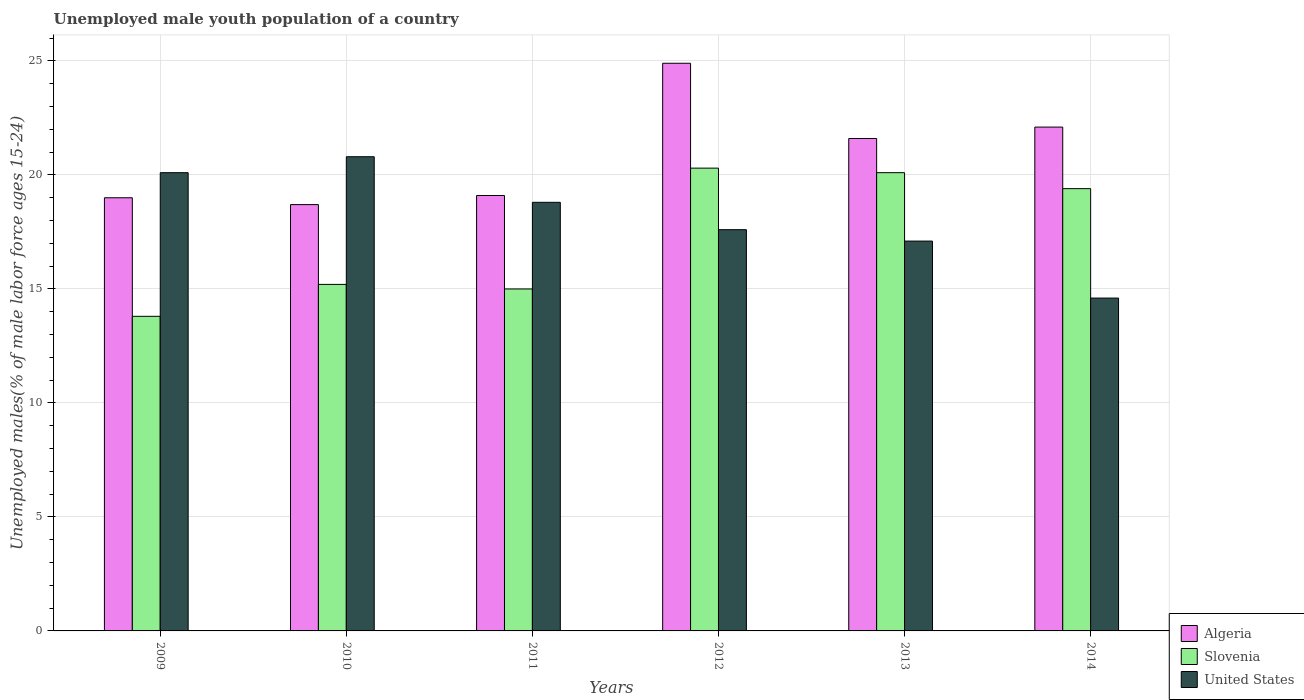How many groups of bars are there?
Your answer should be very brief. 6. Are the number of bars on each tick of the X-axis equal?
Give a very brief answer. Yes. How many bars are there on the 4th tick from the left?
Your answer should be very brief. 3. What is the percentage of unemployed male youth population in Slovenia in 2010?
Your answer should be very brief. 15.2. Across all years, what is the maximum percentage of unemployed male youth population in Slovenia?
Give a very brief answer. 20.3. Across all years, what is the minimum percentage of unemployed male youth population in Slovenia?
Offer a very short reply. 13.8. In which year was the percentage of unemployed male youth population in United States maximum?
Your answer should be very brief. 2010. In which year was the percentage of unemployed male youth population in Slovenia minimum?
Ensure brevity in your answer.  2009. What is the total percentage of unemployed male youth population in Algeria in the graph?
Make the answer very short. 125.4. What is the difference between the percentage of unemployed male youth population in Algeria in 2013 and that in 2014?
Offer a very short reply. -0.5. What is the difference between the percentage of unemployed male youth population in United States in 2014 and the percentage of unemployed male youth population in Slovenia in 2013?
Your answer should be very brief. -5.5. What is the average percentage of unemployed male youth population in United States per year?
Your response must be concise. 18.17. In the year 2014, what is the difference between the percentage of unemployed male youth population in Algeria and percentage of unemployed male youth population in Slovenia?
Your answer should be compact. 2.7. What is the ratio of the percentage of unemployed male youth population in Algeria in 2009 to that in 2011?
Your answer should be very brief. 0.99. Is the percentage of unemployed male youth population in Slovenia in 2010 less than that in 2012?
Your response must be concise. Yes. Is the difference between the percentage of unemployed male youth population in Algeria in 2010 and 2011 greater than the difference between the percentage of unemployed male youth population in Slovenia in 2010 and 2011?
Ensure brevity in your answer.  No. What is the difference between the highest and the second highest percentage of unemployed male youth population in United States?
Give a very brief answer. 0.7. What is the difference between the highest and the lowest percentage of unemployed male youth population in United States?
Offer a very short reply. 6.2. In how many years, is the percentage of unemployed male youth population in Algeria greater than the average percentage of unemployed male youth population in Algeria taken over all years?
Provide a succinct answer. 3. What does the 2nd bar from the left in 2014 represents?
Your answer should be compact. Slovenia. What does the 3rd bar from the right in 2014 represents?
Make the answer very short. Algeria. Is it the case that in every year, the sum of the percentage of unemployed male youth population in Algeria and percentage of unemployed male youth population in Slovenia is greater than the percentage of unemployed male youth population in United States?
Keep it short and to the point. Yes. How many bars are there?
Your answer should be compact. 18. Are all the bars in the graph horizontal?
Make the answer very short. No. How many years are there in the graph?
Provide a succinct answer. 6. Does the graph contain any zero values?
Keep it short and to the point. No. Where does the legend appear in the graph?
Offer a very short reply. Bottom right. What is the title of the graph?
Your answer should be very brief. Unemployed male youth population of a country. Does "Iraq" appear as one of the legend labels in the graph?
Offer a terse response. No. What is the label or title of the Y-axis?
Provide a short and direct response. Unemployed males(% of male labor force ages 15-24). What is the Unemployed males(% of male labor force ages 15-24) of Algeria in 2009?
Ensure brevity in your answer.  19. What is the Unemployed males(% of male labor force ages 15-24) in Slovenia in 2009?
Your response must be concise. 13.8. What is the Unemployed males(% of male labor force ages 15-24) of United States in 2009?
Provide a short and direct response. 20.1. What is the Unemployed males(% of male labor force ages 15-24) of Algeria in 2010?
Provide a short and direct response. 18.7. What is the Unemployed males(% of male labor force ages 15-24) in Slovenia in 2010?
Your response must be concise. 15.2. What is the Unemployed males(% of male labor force ages 15-24) of United States in 2010?
Offer a terse response. 20.8. What is the Unemployed males(% of male labor force ages 15-24) of Algeria in 2011?
Provide a succinct answer. 19.1. What is the Unemployed males(% of male labor force ages 15-24) of United States in 2011?
Your answer should be very brief. 18.8. What is the Unemployed males(% of male labor force ages 15-24) in Algeria in 2012?
Give a very brief answer. 24.9. What is the Unemployed males(% of male labor force ages 15-24) of Slovenia in 2012?
Provide a short and direct response. 20.3. What is the Unemployed males(% of male labor force ages 15-24) in United States in 2012?
Ensure brevity in your answer.  17.6. What is the Unemployed males(% of male labor force ages 15-24) of Algeria in 2013?
Offer a terse response. 21.6. What is the Unemployed males(% of male labor force ages 15-24) in Slovenia in 2013?
Provide a short and direct response. 20.1. What is the Unemployed males(% of male labor force ages 15-24) of United States in 2013?
Offer a very short reply. 17.1. What is the Unemployed males(% of male labor force ages 15-24) in Algeria in 2014?
Your response must be concise. 22.1. What is the Unemployed males(% of male labor force ages 15-24) in Slovenia in 2014?
Offer a very short reply. 19.4. What is the Unemployed males(% of male labor force ages 15-24) of United States in 2014?
Your answer should be compact. 14.6. Across all years, what is the maximum Unemployed males(% of male labor force ages 15-24) in Algeria?
Offer a terse response. 24.9. Across all years, what is the maximum Unemployed males(% of male labor force ages 15-24) of Slovenia?
Your answer should be very brief. 20.3. Across all years, what is the maximum Unemployed males(% of male labor force ages 15-24) in United States?
Ensure brevity in your answer.  20.8. Across all years, what is the minimum Unemployed males(% of male labor force ages 15-24) of Algeria?
Provide a short and direct response. 18.7. Across all years, what is the minimum Unemployed males(% of male labor force ages 15-24) in Slovenia?
Your answer should be very brief. 13.8. Across all years, what is the minimum Unemployed males(% of male labor force ages 15-24) in United States?
Keep it short and to the point. 14.6. What is the total Unemployed males(% of male labor force ages 15-24) of Algeria in the graph?
Make the answer very short. 125.4. What is the total Unemployed males(% of male labor force ages 15-24) of Slovenia in the graph?
Make the answer very short. 103.8. What is the total Unemployed males(% of male labor force ages 15-24) of United States in the graph?
Your response must be concise. 109. What is the difference between the Unemployed males(% of male labor force ages 15-24) of Slovenia in 2009 and that in 2010?
Provide a short and direct response. -1.4. What is the difference between the Unemployed males(% of male labor force ages 15-24) of United States in 2009 and that in 2010?
Offer a terse response. -0.7. What is the difference between the Unemployed males(% of male labor force ages 15-24) of Algeria in 2009 and that in 2011?
Provide a short and direct response. -0.1. What is the difference between the Unemployed males(% of male labor force ages 15-24) of United States in 2009 and that in 2011?
Offer a very short reply. 1.3. What is the difference between the Unemployed males(% of male labor force ages 15-24) of United States in 2009 and that in 2012?
Ensure brevity in your answer.  2.5. What is the difference between the Unemployed males(% of male labor force ages 15-24) of Algeria in 2009 and that in 2014?
Your answer should be very brief. -3.1. What is the difference between the Unemployed males(% of male labor force ages 15-24) in Slovenia in 2010 and that in 2011?
Keep it short and to the point. 0.2. What is the difference between the Unemployed males(% of male labor force ages 15-24) in Algeria in 2010 and that in 2012?
Your answer should be very brief. -6.2. What is the difference between the Unemployed males(% of male labor force ages 15-24) of United States in 2010 and that in 2012?
Ensure brevity in your answer.  3.2. What is the difference between the Unemployed males(% of male labor force ages 15-24) in Algeria in 2010 and that in 2013?
Offer a very short reply. -2.9. What is the difference between the Unemployed males(% of male labor force ages 15-24) of Slovenia in 2010 and that in 2013?
Offer a terse response. -4.9. What is the difference between the Unemployed males(% of male labor force ages 15-24) in Algeria in 2010 and that in 2014?
Keep it short and to the point. -3.4. What is the difference between the Unemployed males(% of male labor force ages 15-24) in Slovenia in 2010 and that in 2014?
Your answer should be very brief. -4.2. What is the difference between the Unemployed males(% of male labor force ages 15-24) of Slovenia in 2011 and that in 2012?
Your answer should be very brief. -5.3. What is the difference between the Unemployed males(% of male labor force ages 15-24) of United States in 2011 and that in 2012?
Your answer should be very brief. 1.2. What is the difference between the Unemployed males(% of male labor force ages 15-24) in Algeria in 2011 and that in 2013?
Your answer should be very brief. -2.5. What is the difference between the Unemployed males(% of male labor force ages 15-24) of Slovenia in 2011 and that in 2013?
Your answer should be very brief. -5.1. What is the difference between the Unemployed males(% of male labor force ages 15-24) in United States in 2011 and that in 2013?
Your answer should be very brief. 1.7. What is the difference between the Unemployed males(% of male labor force ages 15-24) of Algeria in 2011 and that in 2014?
Your answer should be compact. -3. What is the difference between the Unemployed males(% of male labor force ages 15-24) in Slovenia in 2011 and that in 2014?
Ensure brevity in your answer.  -4.4. What is the difference between the Unemployed males(% of male labor force ages 15-24) of Algeria in 2012 and that in 2013?
Your answer should be very brief. 3.3. What is the difference between the Unemployed males(% of male labor force ages 15-24) of Slovenia in 2012 and that in 2013?
Keep it short and to the point. 0.2. What is the difference between the Unemployed males(% of male labor force ages 15-24) of Algeria in 2012 and that in 2014?
Ensure brevity in your answer.  2.8. What is the difference between the Unemployed males(% of male labor force ages 15-24) of Algeria in 2013 and that in 2014?
Offer a terse response. -0.5. What is the difference between the Unemployed males(% of male labor force ages 15-24) in Slovenia in 2013 and that in 2014?
Make the answer very short. 0.7. What is the difference between the Unemployed males(% of male labor force ages 15-24) in Algeria in 2009 and the Unemployed males(% of male labor force ages 15-24) in Slovenia in 2010?
Your response must be concise. 3.8. What is the difference between the Unemployed males(% of male labor force ages 15-24) in Algeria in 2009 and the Unemployed males(% of male labor force ages 15-24) in United States in 2010?
Your answer should be very brief. -1.8. What is the difference between the Unemployed males(% of male labor force ages 15-24) in Algeria in 2009 and the Unemployed males(% of male labor force ages 15-24) in Slovenia in 2011?
Keep it short and to the point. 4. What is the difference between the Unemployed males(% of male labor force ages 15-24) of Algeria in 2009 and the Unemployed males(% of male labor force ages 15-24) of United States in 2011?
Ensure brevity in your answer.  0.2. What is the difference between the Unemployed males(% of male labor force ages 15-24) of Slovenia in 2009 and the Unemployed males(% of male labor force ages 15-24) of United States in 2011?
Provide a short and direct response. -5. What is the difference between the Unemployed males(% of male labor force ages 15-24) in Slovenia in 2009 and the Unemployed males(% of male labor force ages 15-24) in United States in 2013?
Offer a very short reply. -3.3. What is the difference between the Unemployed males(% of male labor force ages 15-24) in Slovenia in 2009 and the Unemployed males(% of male labor force ages 15-24) in United States in 2014?
Make the answer very short. -0.8. What is the difference between the Unemployed males(% of male labor force ages 15-24) in Algeria in 2010 and the Unemployed males(% of male labor force ages 15-24) in Slovenia in 2011?
Provide a succinct answer. 3.7. What is the difference between the Unemployed males(% of male labor force ages 15-24) in Algeria in 2010 and the Unemployed males(% of male labor force ages 15-24) in United States in 2012?
Keep it short and to the point. 1.1. What is the difference between the Unemployed males(% of male labor force ages 15-24) in Algeria in 2010 and the Unemployed males(% of male labor force ages 15-24) in United States in 2013?
Your answer should be compact. 1.6. What is the difference between the Unemployed males(% of male labor force ages 15-24) of Slovenia in 2010 and the Unemployed males(% of male labor force ages 15-24) of United States in 2013?
Make the answer very short. -1.9. What is the difference between the Unemployed males(% of male labor force ages 15-24) of Algeria in 2010 and the Unemployed males(% of male labor force ages 15-24) of Slovenia in 2014?
Provide a succinct answer. -0.7. What is the difference between the Unemployed males(% of male labor force ages 15-24) in Algeria in 2010 and the Unemployed males(% of male labor force ages 15-24) in United States in 2014?
Give a very brief answer. 4.1. What is the difference between the Unemployed males(% of male labor force ages 15-24) in Algeria in 2011 and the Unemployed males(% of male labor force ages 15-24) in Slovenia in 2012?
Ensure brevity in your answer.  -1.2. What is the difference between the Unemployed males(% of male labor force ages 15-24) of Algeria in 2011 and the Unemployed males(% of male labor force ages 15-24) of United States in 2012?
Provide a short and direct response. 1.5. What is the difference between the Unemployed males(% of male labor force ages 15-24) in Algeria in 2011 and the Unemployed males(% of male labor force ages 15-24) in Slovenia in 2013?
Ensure brevity in your answer.  -1. What is the difference between the Unemployed males(% of male labor force ages 15-24) of Slovenia in 2011 and the Unemployed males(% of male labor force ages 15-24) of United States in 2013?
Ensure brevity in your answer.  -2.1. What is the difference between the Unemployed males(% of male labor force ages 15-24) of Algeria in 2011 and the Unemployed males(% of male labor force ages 15-24) of Slovenia in 2014?
Ensure brevity in your answer.  -0.3. What is the difference between the Unemployed males(% of male labor force ages 15-24) in Algeria in 2011 and the Unemployed males(% of male labor force ages 15-24) in United States in 2014?
Your answer should be very brief. 4.5. What is the difference between the Unemployed males(% of male labor force ages 15-24) of Algeria in 2012 and the Unemployed males(% of male labor force ages 15-24) of Slovenia in 2013?
Provide a short and direct response. 4.8. What is the difference between the Unemployed males(% of male labor force ages 15-24) in Slovenia in 2012 and the Unemployed males(% of male labor force ages 15-24) in United States in 2013?
Offer a very short reply. 3.2. What is the difference between the Unemployed males(% of male labor force ages 15-24) of Algeria in 2013 and the Unemployed males(% of male labor force ages 15-24) of Slovenia in 2014?
Provide a succinct answer. 2.2. What is the average Unemployed males(% of male labor force ages 15-24) of Algeria per year?
Ensure brevity in your answer.  20.9. What is the average Unemployed males(% of male labor force ages 15-24) of United States per year?
Offer a terse response. 18.17. In the year 2009, what is the difference between the Unemployed males(% of male labor force ages 15-24) in Algeria and Unemployed males(% of male labor force ages 15-24) in United States?
Make the answer very short. -1.1. In the year 2009, what is the difference between the Unemployed males(% of male labor force ages 15-24) in Slovenia and Unemployed males(% of male labor force ages 15-24) in United States?
Your answer should be compact. -6.3. In the year 2010, what is the difference between the Unemployed males(% of male labor force ages 15-24) in Algeria and Unemployed males(% of male labor force ages 15-24) in United States?
Ensure brevity in your answer.  -2.1. In the year 2010, what is the difference between the Unemployed males(% of male labor force ages 15-24) in Slovenia and Unemployed males(% of male labor force ages 15-24) in United States?
Ensure brevity in your answer.  -5.6. In the year 2012, what is the difference between the Unemployed males(% of male labor force ages 15-24) of Algeria and Unemployed males(% of male labor force ages 15-24) of Slovenia?
Make the answer very short. 4.6. In the year 2012, what is the difference between the Unemployed males(% of male labor force ages 15-24) in Algeria and Unemployed males(% of male labor force ages 15-24) in United States?
Provide a short and direct response. 7.3. In the year 2012, what is the difference between the Unemployed males(% of male labor force ages 15-24) of Slovenia and Unemployed males(% of male labor force ages 15-24) of United States?
Offer a very short reply. 2.7. In the year 2013, what is the difference between the Unemployed males(% of male labor force ages 15-24) of Algeria and Unemployed males(% of male labor force ages 15-24) of United States?
Ensure brevity in your answer.  4.5. In the year 2013, what is the difference between the Unemployed males(% of male labor force ages 15-24) of Slovenia and Unemployed males(% of male labor force ages 15-24) of United States?
Give a very brief answer. 3. In the year 2014, what is the difference between the Unemployed males(% of male labor force ages 15-24) in Algeria and Unemployed males(% of male labor force ages 15-24) in United States?
Your answer should be compact. 7.5. In the year 2014, what is the difference between the Unemployed males(% of male labor force ages 15-24) of Slovenia and Unemployed males(% of male labor force ages 15-24) of United States?
Your answer should be very brief. 4.8. What is the ratio of the Unemployed males(% of male labor force ages 15-24) in Slovenia in 2009 to that in 2010?
Offer a terse response. 0.91. What is the ratio of the Unemployed males(% of male labor force ages 15-24) of United States in 2009 to that in 2010?
Make the answer very short. 0.97. What is the ratio of the Unemployed males(% of male labor force ages 15-24) in United States in 2009 to that in 2011?
Your answer should be very brief. 1.07. What is the ratio of the Unemployed males(% of male labor force ages 15-24) of Algeria in 2009 to that in 2012?
Your answer should be compact. 0.76. What is the ratio of the Unemployed males(% of male labor force ages 15-24) of Slovenia in 2009 to that in 2012?
Keep it short and to the point. 0.68. What is the ratio of the Unemployed males(% of male labor force ages 15-24) of United States in 2009 to that in 2012?
Provide a succinct answer. 1.14. What is the ratio of the Unemployed males(% of male labor force ages 15-24) of Algeria in 2009 to that in 2013?
Provide a short and direct response. 0.88. What is the ratio of the Unemployed males(% of male labor force ages 15-24) in Slovenia in 2009 to that in 2013?
Offer a very short reply. 0.69. What is the ratio of the Unemployed males(% of male labor force ages 15-24) of United States in 2009 to that in 2013?
Your answer should be very brief. 1.18. What is the ratio of the Unemployed males(% of male labor force ages 15-24) of Algeria in 2009 to that in 2014?
Provide a succinct answer. 0.86. What is the ratio of the Unemployed males(% of male labor force ages 15-24) in Slovenia in 2009 to that in 2014?
Make the answer very short. 0.71. What is the ratio of the Unemployed males(% of male labor force ages 15-24) of United States in 2009 to that in 2014?
Your response must be concise. 1.38. What is the ratio of the Unemployed males(% of male labor force ages 15-24) of Algeria in 2010 to that in 2011?
Ensure brevity in your answer.  0.98. What is the ratio of the Unemployed males(% of male labor force ages 15-24) of Slovenia in 2010 to that in 2011?
Your response must be concise. 1.01. What is the ratio of the Unemployed males(% of male labor force ages 15-24) in United States in 2010 to that in 2011?
Provide a succinct answer. 1.11. What is the ratio of the Unemployed males(% of male labor force ages 15-24) in Algeria in 2010 to that in 2012?
Offer a terse response. 0.75. What is the ratio of the Unemployed males(% of male labor force ages 15-24) of Slovenia in 2010 to that in 2012?
Provide a short and direct response. 0.75. What is the ratio of the Unemployed males(% of male labor force ages 15-24) in United States in 2010 to that in 2012?
Offer a very short reply. 1.18. What is the ratio of the Unemployed males(% of male labor force ages 15-24) of Algeria in 2010 to that in 2013?
Offer a terse response. 0.87. What is the ratio of the Unemployed males(% of male labor force ages 15-24) in Slovenia in 2010 to that in 2013?
Give a very brief answer. 0.76. What is the ratio of the Unemployed males(% of male labor force ages 15-24) of United States in 2010 to that in 2013?
Provide a short and direct response. 1.22. What is the ratio of the Unemployed males(% of male labor force ages 15-24) in Algeria in 2010 to that in 2014?
Your answer should be very brief. 0.85. What is the ratio of the Unemployed males(% of male labor force ages 15-24) of Slovenia in 2010 to that in 2014?
Give a very brief answer. 0.78. What is the ratio of the Unemployed males(% of male labor force ages 15-24) in United States in 2010 to that in 2014?
Offer a very short reply. 1.42. What is the ratio of the Unemployed males(% of male labor force ages 15-24) in Algeria in 2011 to that in 2012?
Provide a succinct answer. 0.77. What is the ratio of the Unemployed males(% of male labor force ages 15-24) in Slovenia in 2011 to that in 2012?
Your response must be concise. 0.74. What is the ratio of the Unemployed males(% of male labor force ages 15-24) in United States in 2011 to that in 2012?
Ensure brevity in your answer.  1.07. What is the ratio of the Unemployed males(% of male labor force ages 15-24) of Algeria in 2011 to that in 2013?
Your answer should be compact. 0.88. What is the ratio of the Unemployed males(% of male labor force ages 15-24) in Slovenia in 2011 to that in 2013?
Ensure brevity in your answer.  0.75. What is the ratio of the Unemployed males(% of male labor force ages 15-24) in United States in 2011 to that in 2013?
Offer a very short reply. 1.1. What is the ratio of the Unemployed males(% of male labor force ages 15-24) in Algeria in 2011 to that in 2014?
Your answer should be compact. 0.86. What is the ratio of the Unemployed males(% of male labor force ages 15-24) of Slovenia in 2011 to that in 2014?
Give a very brief answer. 0.77. What is the ratio of the Unemployed males(% of male labor force ages 15-24) in United States in 2011 to that in 2014?
Give a very brief answer. 1.29. What is the ratio of the Unemployed males(% of male labor force ages 15-24) of Algeria in 2012 to that in 2013?
Keep it short and to the point. 1.15. What is the ratio of the Unemployed males(% of male labor force ages 15-24) in United States in 2012 to that in 2013?
Provide a succinct answer. 1.03. What is the ratio of the Unemployed males(% of male labor force ages 15-24) of Algeria in 2012 to that in 2014?
Provide a succinct answer. 1.13. What is the ratio of the Unemployed males(% of male labor force ages 15-24) of Slovenia in 2012 to that in 2014?
Your response must be concise. 1.05. What is the ratio of the Unemployed males(% of male labor force ages 15-24) in United States in 2012 to that in 2014?
Give a very brief answer. 1.21. What is the ratio of the Unemployed males(% of male labor force ages 15-24) of Algeria in 2013 to that in 2014?
Make the answer very short. 0.98. What is the ratio of the Unemployed males(% of male labor force ages 15-24) of Slovenia in 2013 to that in 2014?
Your answer should be compact. 1.04. What is the ratio of the Unemployed males(% of male labor force ages 15-24) of United States in 2013 to that in 2014?
Provide a short and direct response. 1.17. What is the difference between the highest and the second highest Unemployed males(% of male labor force ages 15-24) in United States?
Offer a terse response. 0.7. What is the difference between the highest and the lowest Unemployed males(% of male labor force ages 15-24) of United States?
Your answer should be compact. 6.2. 